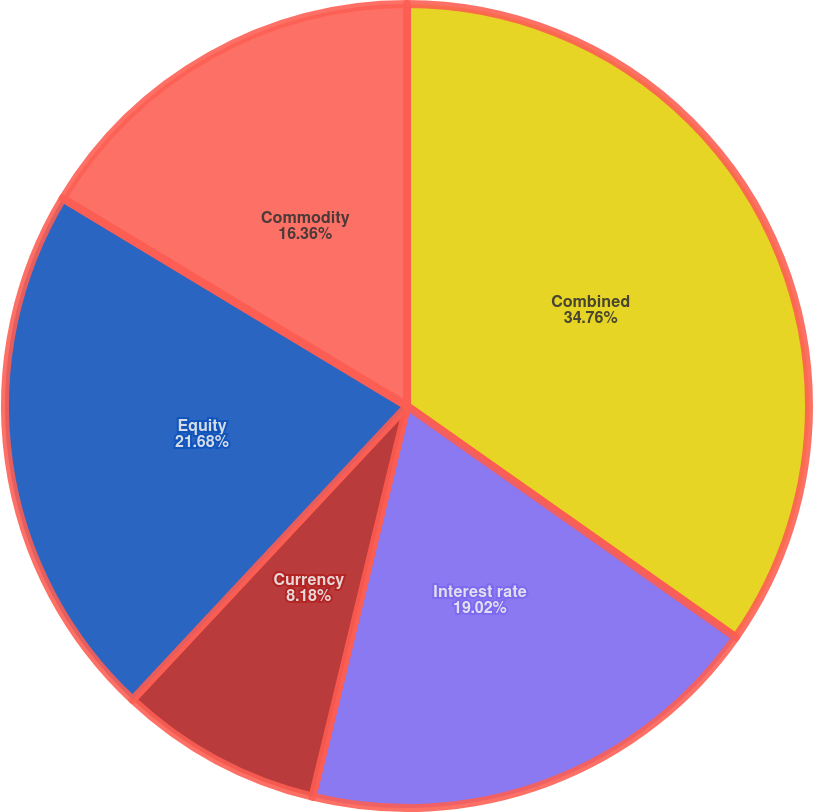Convert chart. <chart><loc_0><loc_0><loc_500><loc_500><pie_chart><fcel>Combined<fcel>Interest rate<fcel>Currency<fcel>Equity<fcel>Commodity<nl><fcel>34.76%<fcel>19.02%<fcel>8.18%<fcel>21.68%<fcel>16.36%<nl></chart> 